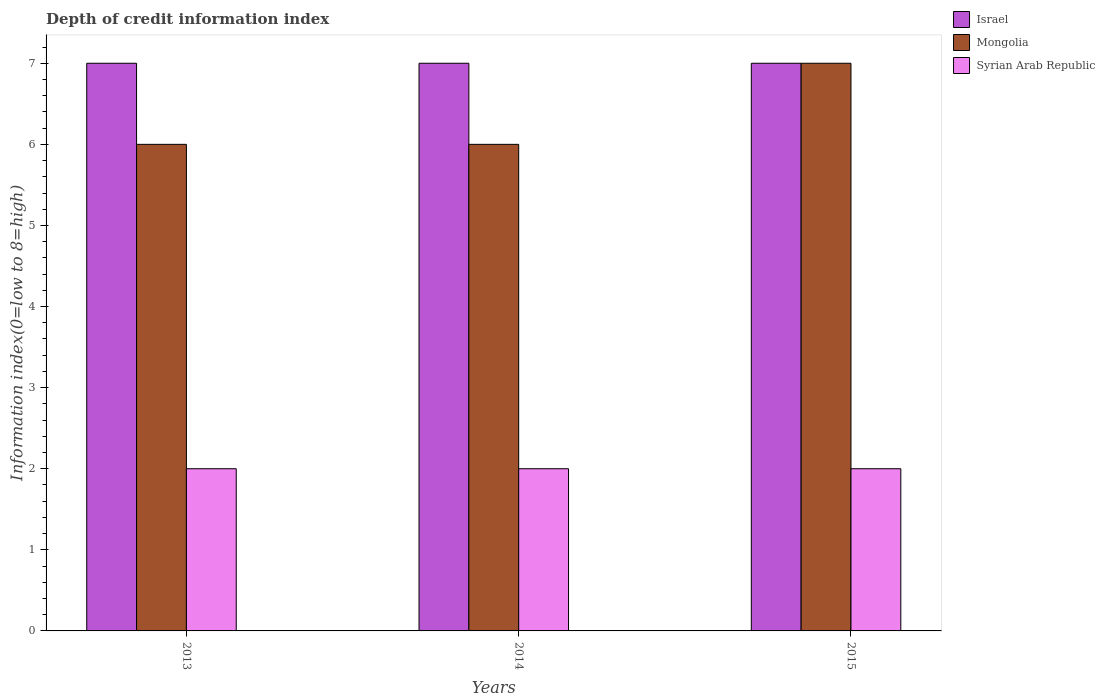Are the number of bars per tick equal to the number of legend labels?
Your answer should be very brief. Yes. How many bars are there on the 1st tick from the left?
Provide a short and direct response. 3. What is the information index in Israel in 2013?
Provide a succinct answer. 7. Across all years, what is the maximum information index in Syrian Arab Republic?
Ensure brevity in your answer.  2. Across all years, what is the minimum information index in Syrian Arab Republic?
Offer a very short reply. 2. In which year was the information index in Mongolia maximum?
Ensure brevity in your answer.  2015. In which year was the information index in Syrian Arab Republic minimum?
Your answer should be compact. 2013. What is the total information index in Mongolia in the graph?
Your response must be concise. 19. What is the difference between the information index in Israel in 2014 and that in 2015?
Your answer should be compact. 0. What is the difference between the information index in Mongolia in 2015 and the information index in Israel in 2014?
Provide a succinct answer. 0. What is the average information index in Israel per year?
Keep it short and to the point. 7. In the year 2015, what is the difference between the information index in Mongolia and information index in Syrian Arab Republic?
Your answer should be compact. 5. In how many years, is the information index in Mongolia greater than 6?
Give a very brief answer. 1. What is the ratio of the information index in Syrian Arab Republic in 2013 to that in 2015?
Your response must be concise. 1. Is the difference between the information index in Mongolia in 2013 and 2014 greater than the difference between the information index in Syrian Arab Republic in 2013 and 2014?
Your answer should be compact. No. What is the difference between the highest and the second highest information index in Israel?
Provide a short and direct response. 0. What is the difference between the highest and the lowest information index in Syrian Arab Republic?
Give a very brief answer. 0. Is the sum of the information index in Mongolia in 2013 and 2014 greater than the maximum information index in Syrian Arab Republic across all years?
Provide a succinct answer. Yes. What does the 3rd bar from the left in 2015 represents?
Your answer should be compact. Syrian Arab Republic. How many bars are there?
Keep it short and to the point. 9. Where does the legend appear in the graph?
Keep it short and to the point. Top right. How many legend labels are there?
Your response must be concise. 3. What is the title of the graph?
Make the answer very short. Depth of credit information index. Does "Guinea" appear as one of the legend labels in the graph?
Ensure brevity in your answer.  No. What is the label or title of the X-axis?
Make the answer very short. Years. What is the label or title of the Y-axis?
Ensure brevity in your answer.  Information index(0=low to 8=high). What is the Information index(0=low to 8=high) in Syrian Arab Republic in 2013?
Offer a very short reply. 2. What is the Information index(0=low to 8=high) in Syrian Arab Republic in 2015?
Provide a short and direct response. 2. Across all years, what is the maximum Information index(0=low to 8=high) of Israel?
Ensure brevity in your answer.  7. Across all years, what is the maximum Information index(0=low to 8=high) of Mongolia?
Your answer should be compact. 7. Across all years, what is the maximum Information index(0=low to 8=high) in Syrian Arab Republic?
Your answer should be compact. 2. Across all years, what is the minimum Information index(0=low to 8=high) of Israel?
Offer a terse response. 7. What is the total Information index(0=low to 8=high) in Israel in the graph?
Your response must be concise. 21. What is the total Information index(0=low to 8=high) of Mongolia in the graph?
Offer a very short reply. 19. What is the total Information index(0=low to 8=high) in Syrian Arab Republic in the graph?
Offer a very short reply. 6. What is the difference between the Information index(0=low to 8=high) in Israel in 2013 and that in 2014?
Your response must be concise. 0. What is the difference between the Information index(0=low to 8=high) in Syrian Arab Republic in 2013 and that in 2015?
Keep it short and to the point. 0. What is the difference between the Information index(0=low to 8=high) of Mongolia in 2014 and that in 2015?
Offer a very short reply. -1. What is the difference between the Information index(0=low to 8=high) in Syrian Arab Republic in 2014 and that in 2015?
Your answer should be very brief. 0. What is the difference between the Information index(0=low to 8=high) in Israel in 2013 and the Information index(0=low to 8=high) in Mongolia in 2015?
Your answer should be very brief. 0. What is the difference between the Information index(0=low to 8=high) in Israel in 2013 and the Information index(0=low to 8=high) in Syrian Arab Republic in 2015?
Your response must be concise. 5. What is the difference between the Information index(0=low to 8=high) of Israel in 2014 and the Information index(0=low to 8=high) of Mongolia in 2015?
Provide a succinct answer. 0. What is the difference between the Information index(0=low to 8=high) of Mongolia in 2014 and the Information index(0=low to 8=high) of Syrian Arab Republic in 2015?
Offer a very short reply. 4. What is the average Information index(0=low to 8=high) in Israel per year?
Offer a very short reply. 7. What is the average Information index(0=low to 8=high) of Mongolia per year?
Your response must be concise. 6.33. In the year 2013, what is the difference between the Information index(0=low to 8=high) of Israel and Information index(0=low to 8=high) of Mongolia?
Provide a short and direct response. 1. In the year 2014, what is the difference between the Information index(0=low to 8=high) in Mongolia and Information index(0=low to 8=high) in Syrian Arab Republic?
Offer a very short reply. 4. In the year 2015, what is the difference between the Information index(0=low to 8=high) in Israel and Information index(0=low to 8=high) in Mongolia?
Offer a terse response. 0. What is the ratio of the Information index(0=low to 8=high) of Israel in 2013 to that in 2014?
Provide a succinct answer. 1. What is the ratio of the Information index(0=low to 8=high) of Syrian Arab Republic in 2013 to that in 2014?
Give a very brief answer. 1. What is the ratio of the Information index(0=low to 8=high) of Israel in 2013 to that in 2015?
Ensure brevity in your answer.  1. What is the ratio of the Information index(0=low to 8=high) in Mongolia in 2013 to that in 2015?
Give a very brief answer. 0.86. What is the ratio of the Information index(0=low to 8=high) in Israel in 2014 to that in 2015?
Your answer should be compact. 1. What is the ratio of the Information index(0=low to 8=high) in Syrian Arab Republic in 2014 to that in 2015?
Your answer should be very brief. 1. What is the difference between the highest and the second highest Information index(0=low to 8=high) of Israel?
Give a very brief answer. 0. What is the difference between the highest and the second highest Information index(0=low to 8=high) of Mongolia?
Offer a very short reply. 1. What is the difference between the highest and the second highest Information index(0=low to 8=high) of Syrian Arab Republic?
Provide a succinct answer. 0. What is the difference between the highest and the lowest Information index(0=low to 8=high) of Israel?
Your answer should be compact. 0. What is the difference between the highest and the lowest Information index(0=low to 8=high) in Mongolia?
Give a very brief answer. 1. What is the difference between the highest and the lowest Information index(0=low to 8=high) of Syrian Arab Republic?
Offer a very short reply. 0. 